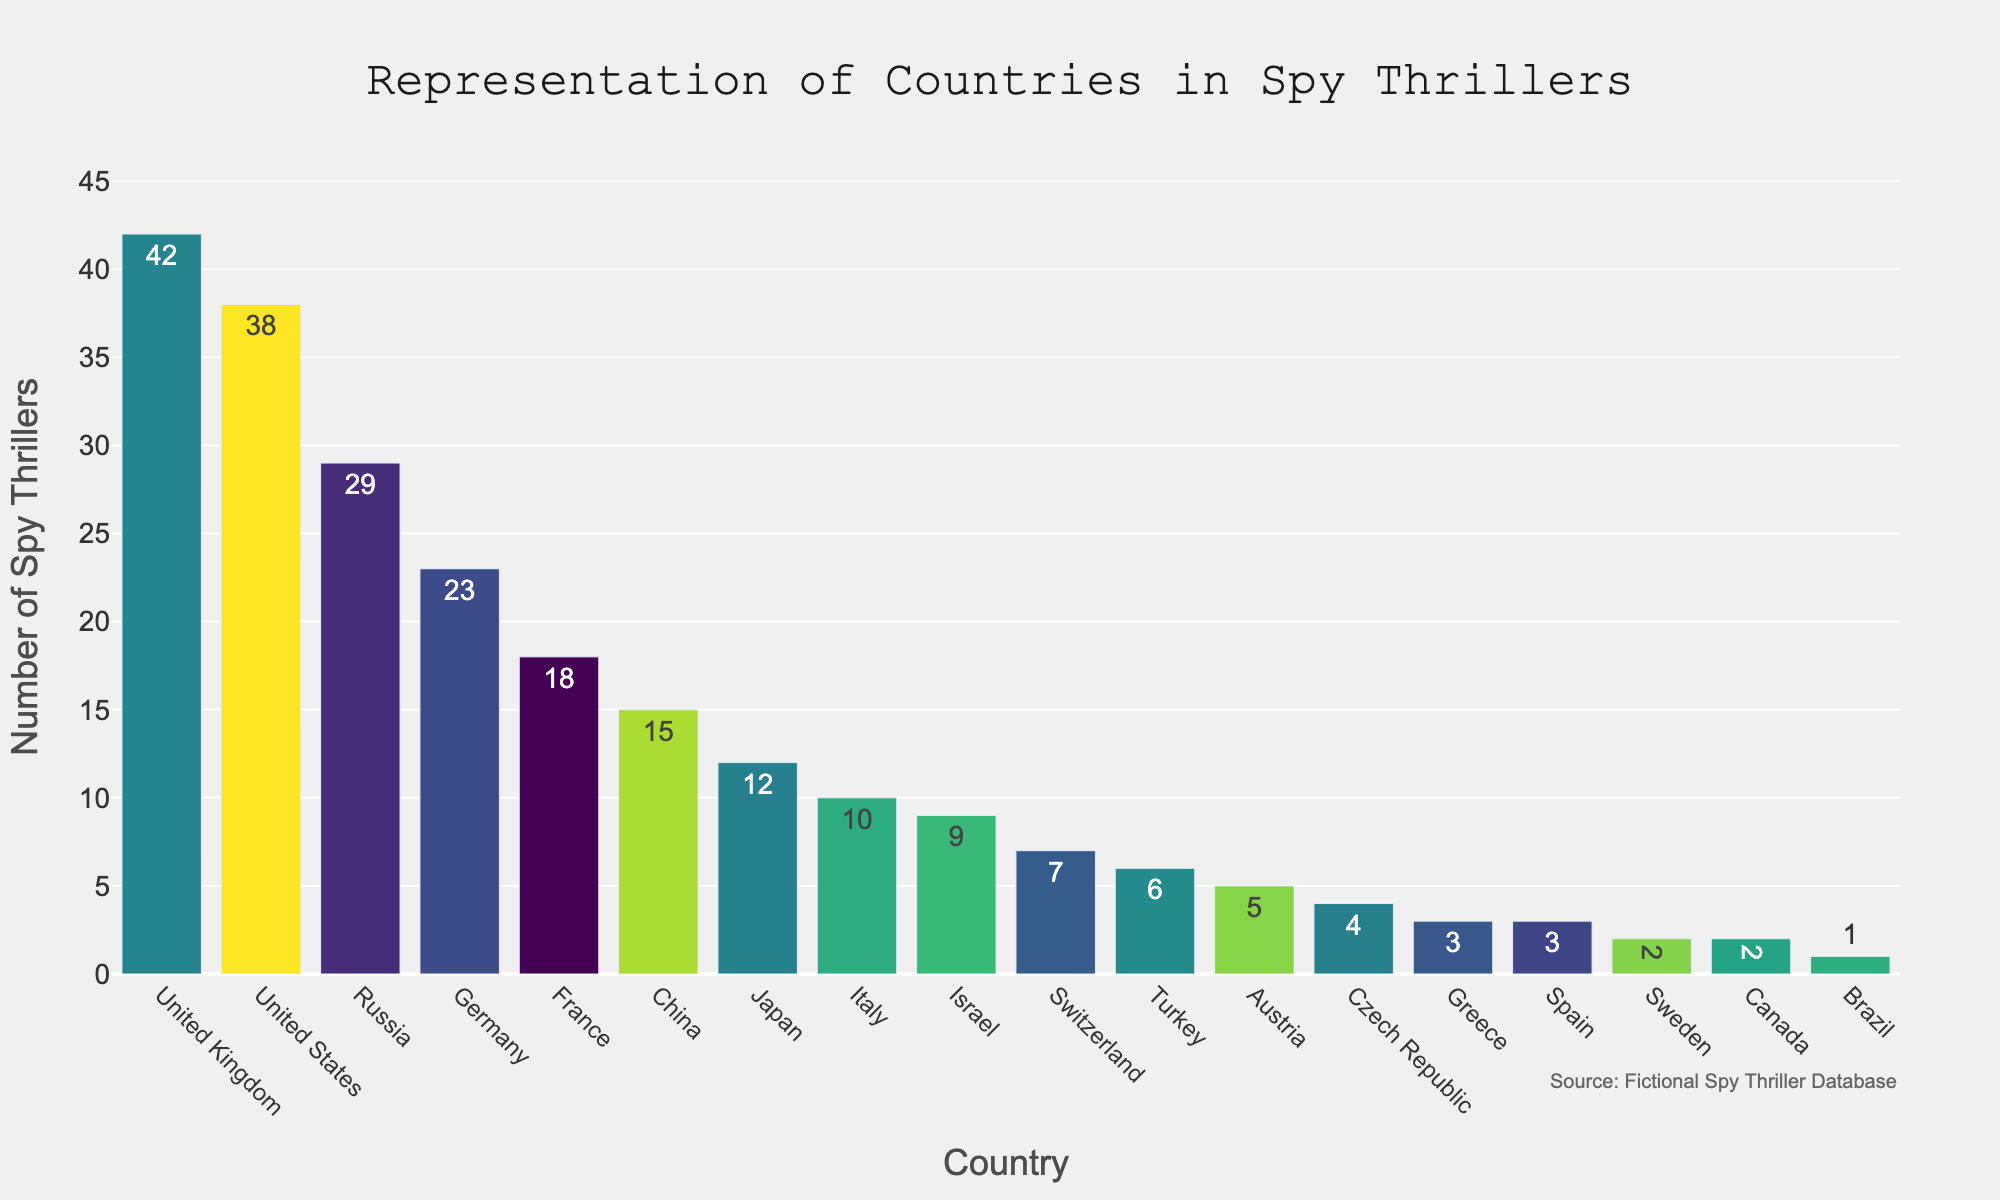Which country is represented the most in spy thrillers? The country represented the most can be identified by the tallest bar in the figure, which is labeled with the highest number. The United Kingdom has the tallest bar, labeled with 42.
Answer: United Kingdom Which country is represented the least in spy thrillers? The country represented the least can be identified by the shortest bar in the figure, which is labeled with the lowest number. Brazil has the shortest bar, labeled with 1.
Answer: Brazil How many more spy thrillers are set in the United Kingdom than in the United States? To find the difference, look at the bars for the United Kingdom and the United States. The United Kingdom has 42 spy thrillers, and the United States has 38. Subtract 38 from 42 to get the difference.
Answer: 4 Are there more spy thrillers set in China or in Japan? Compare the heights and labels of the bars for China and Japan. China has 15 spy thrillers, while Japan has 12. Therefore, there are more in China.
Answer: China What is the sum of spy thrillers set in Germany, France, and Italy? Add the numbers labeled on the bars for Germany, France, and Italy. Germany has 23, France has 18, and Italy has 10. The sum is 23 + 18 + 10.
Answer: 51 Which two countries have an equal number of spy thrillers? Look for bars that have the same height and same labeled numbers. Sweden and Canada both have bars with a height labeled as 2.
Answer: Sweden and Canada How many countries have more than 20 spy thrillers set in them? Count the number of bars with a value greater than 20 in the figure. The countries are the United Kingdom, United States, Germany, and Russia.
Answer: 4 What is the average number of spy thrillers set in Israel and Switzerland? Add the numbers labeled for Israel and Switzerland, then divide by 2. Israel has 9 and Switzerland has 7. The average is (9 + 7) / 2.
Answer: 8 Which has fewer spy thrillers: Austria or Turkey? Compare the heights and labels of the bars for Austria and Turkey. Austria has 5, and Turkey has 6. Thus, Austria has fewer.
Answer: Austria 